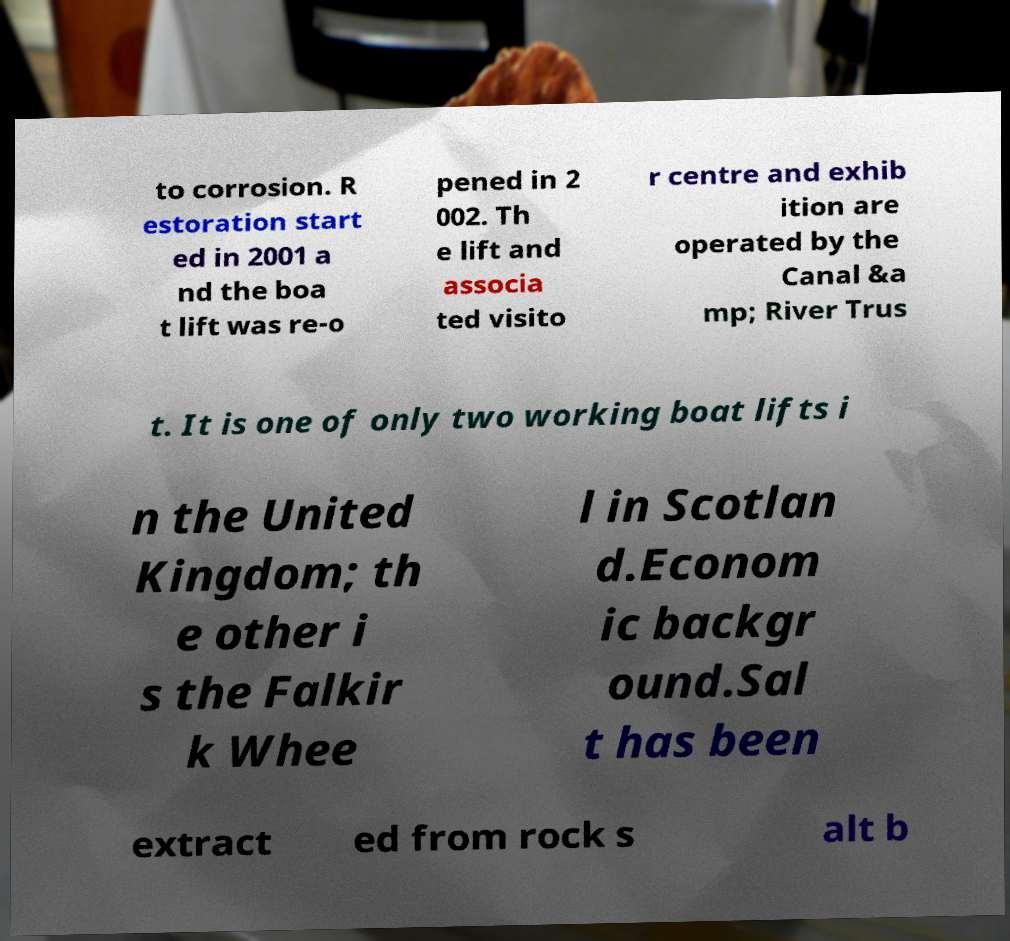For documentation purposes, I need the text within this image transcribed. Could you provide that? to corrosion. R estoration start ed in 2001 a nd the boa t lift was re-o pened in 2 002. Th e lift and associa ted visito r centre and exhib ition are operated by the Canal &a mp; River Trus t. It is one of only two working boat lifts i n the United Kingdom; th e other i s the Falkir k Whee l in Scotlan d.Econom ic backgr ound.Sal t has been extract ed from rock s alt b 